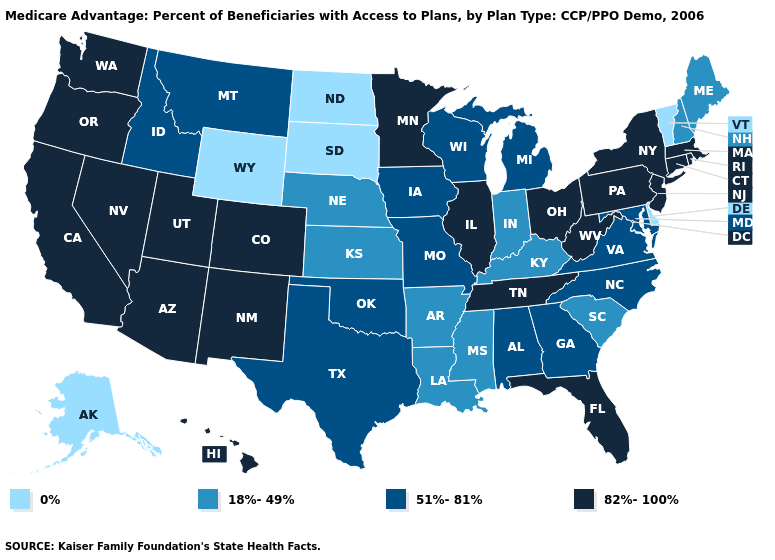What is the lowest value in states that border Colorado?
Short answer required. 0%. Name the states that have a value in the range 82%-100%?
Write a very short answer. Arizona, California, Colorado, Connecticut, Florida, Hawaii, Illinois, Massachusetts, Minnesota, New Jersey, New Mexico, Nevada, New York, Ohio, Oregon, Pennsylvania, Rhode Island, Tennessee, Utah, Washington, West Virginia. Among the states that border Vermont , which have the lowest value?
Concise answer only. New Hampshire. What is the highest value in states that border Vermont?
Give a very brief answer. 82%-100%. Does Montana have the highest value in the USA?
Give a very brief answer. No. What is the value of Kansas?
Be succinct. 18%-49%. Which states hav the highest value in the South?
Be succinct. Florida, Tennessee, West Virginia. What is the highest value in the USA?
Quick response, please. 82%-100%. What is the value of Utah?
Answer briefly. 82%-100%. What is the value of Hawaii?
Be succinct. 82%-100%. What is the lowest value in states that border Utah?
Be succinct. 0%. Does the first symbol in the legend represent the smallest category?
Short answer required. Yes. Name the states that have a value in the range 51%-81%?
Quick response, please. Alabama, Georgia, Iowa, Idaho, Maryland, Michigan, Missouri, Montana, North Carolina, Oklahoma, Texas, Virginia, Wisconsin. Does North Carolina have the same value as Utah?
Be succinct. No. What is the value of California?
Give a very brief answer. 82%-100%. 